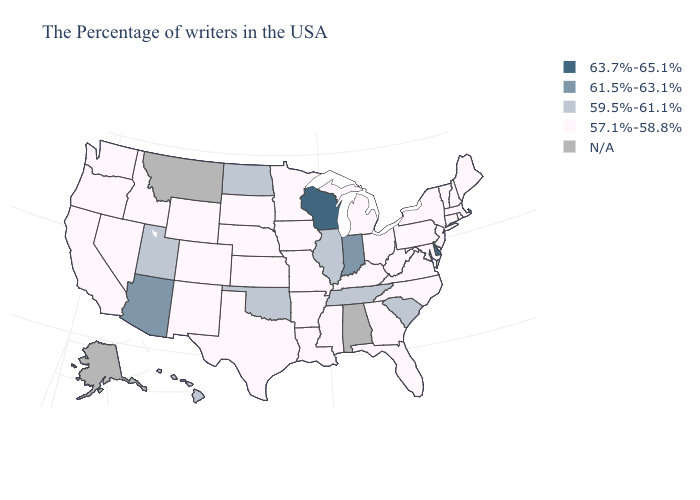What is the lowest value in the Northeast?
Concise answer only. 57.1%-58.8%. What is the value of Georgia?
Write a very short answer. 57.1%-58.8%. What is the lowest value in the Northeast?
Be succinct. 57.1%-58.8%. What is the highest value in the USA?
Concise answer only. 63.7%-65.1%. What is the value of Georgia?
Write a very short answer. 57.1%-58.8%. Name the states that have a value in the range 59.5%-61.1%?
Concise answer only. South Carolina, Tennessee, Illinois, Oklahoma, North Dakota, Utah, Hawaii. Name the states that have a value in the range 63.7%-65.1%?
Short answer required. Delaware, Wisconsin. Which states hav the highest value in the Northeast?
Answer briefly. Maine, Massachusetts, Rhode Island, New Hampshire, Vermont, Connecticut, New York, New Jersey, Pennsylvania. What is the highest value in the South ?
Give a very brief answer. 63.7%-65.1%. What is the highest value in the USA?
Quick response, please. 63.7%-65.1%. Which states hav the highest value in the West?
Answer briefly. Arizona. Name the states that have a value in the range 57.1%-58.8%?
Answer briefly. Maine, Massachusetts, Rhode Island, New Hampshire, Vermont, Connecticut, New York, New Jersey, Maryland, Pennsylvania, Virginia, North Carolina, West Virginia, Ohio, Florida, Georgia, Michigan, Kentucky, Mississippi, Louisiana, Missouri, Arkansas, Minnesota, Iowa, Kansas, Nebraska, Texas, South Dakota, Wyoming, Colorado, New Mexico, Idaho, Nevada, California, Washington, Oregon. Among the states that border Nevada , does Idaho have the highest value?
Concise answer only. No. 